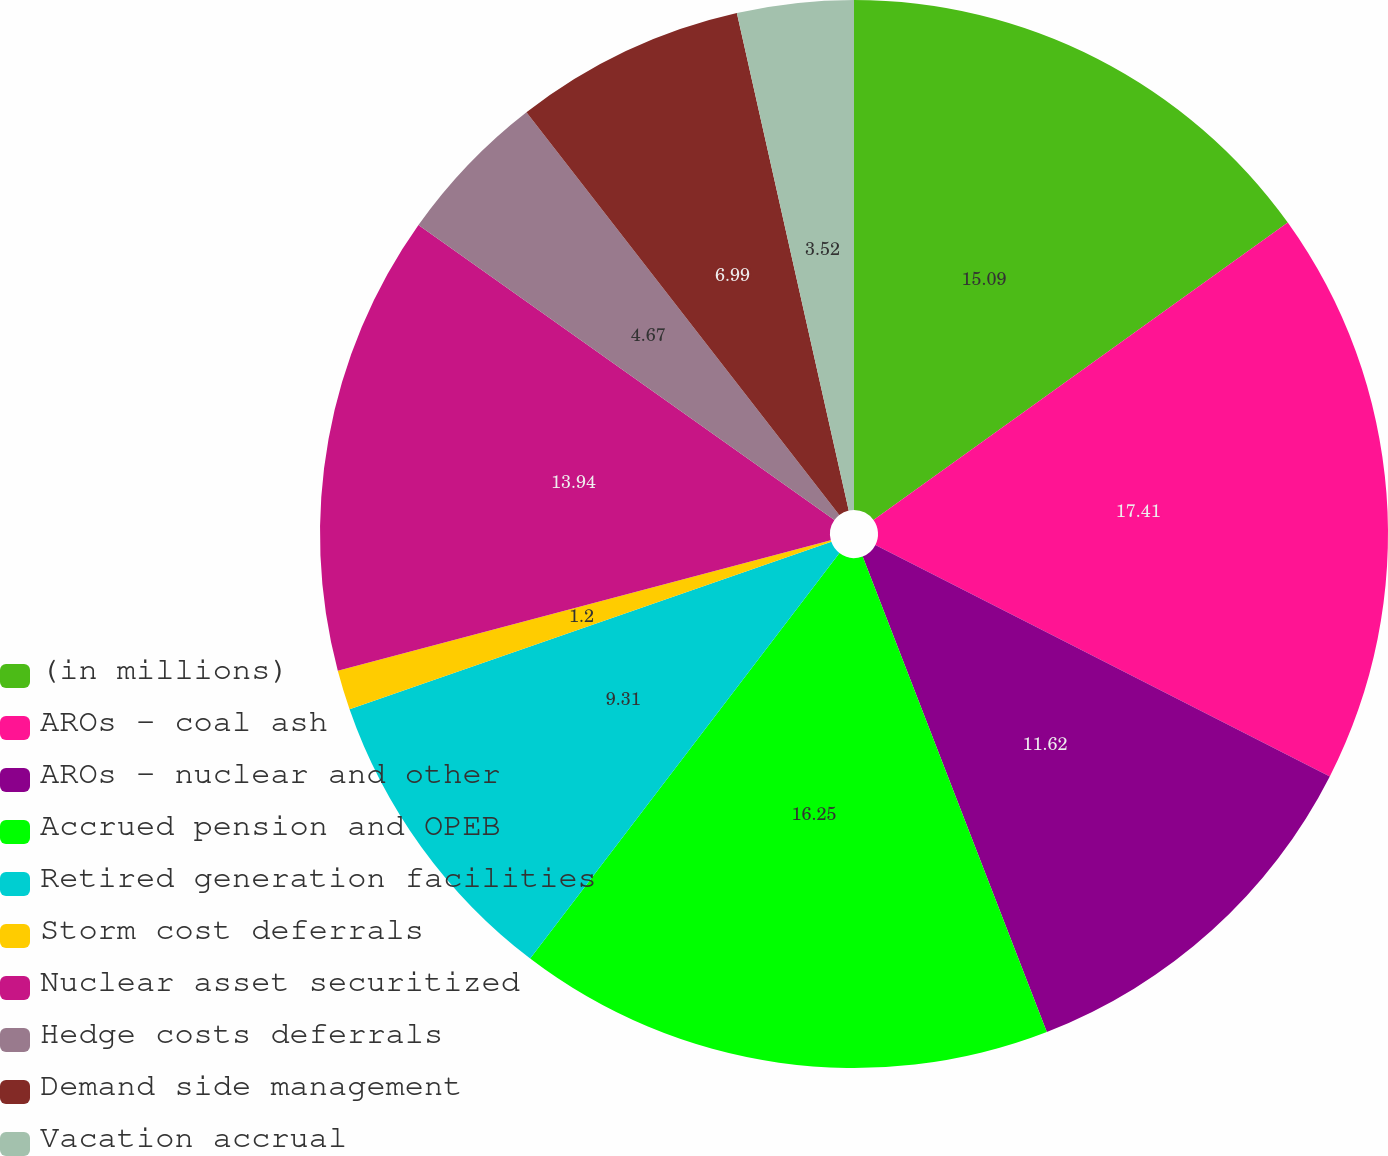Convert chart. <chart><loc_0><loc_0><loc_500><loc_500><pie_chart><fcel>(in millions)<fcel>AROs - coal ash<fcel>AROs - nuclear and other<fcel>Accrued pension and OPEB<fcel>Retired generation facilities<fcel>Storm cost deferrals<fcel>Nuclear asset securitized<fcel>Hedge costs deferrals<fcel>Demand side management<fcel>Vacation accrual<nl><fcel>15.09%<fcel>17.41%<fcel>11.62%<fcel>16.25%<fcel>9.31%<fcel>1.2%<fcel>13.94%<fcel>4.67%<fcel>6.99%<fcel>3.52%<nl></chart> 